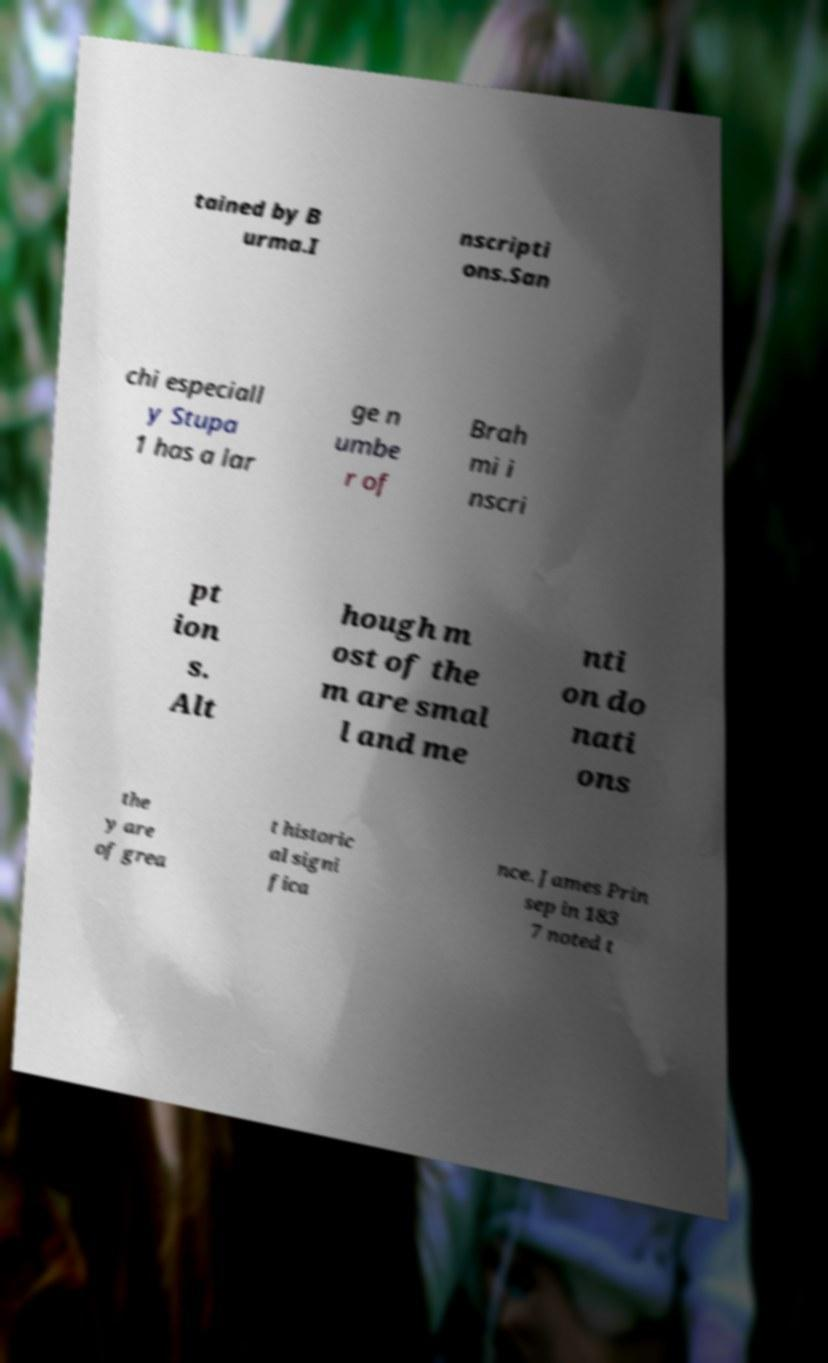Please read and relay the text visible in this image. What does it say? tained by B urma.I nscripti ons.San chi especiall y Stupa 1 has a lar ge n umbe r of Brah mi i nscri pt ion s. Alt hough m ost of the m are smal l and me nti on do nati ons the y are of grea t historic al signi fica nce. James Prin sep in 183 7 noted t 